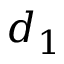Convert formula to latex. <formula><loc_0><loc_0><loc_500><loc_500>d _ { 1 }</formula> 